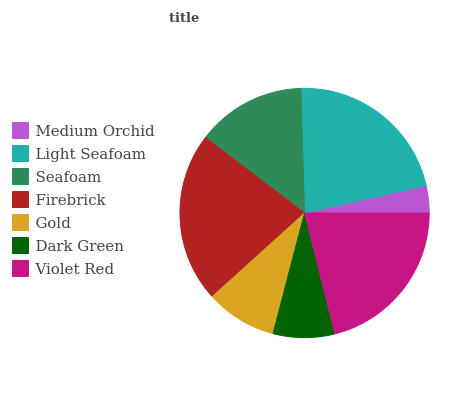Is Medium Orchid the minimum?
Answer yes or no. Yes. Is Firebrick the maximum?
Answer yes or no. Yes. Is Light Seafoam the minimum?
Answer yes or no. No. Is Light Seafoam the maximum?
Answer yes or no. No. Is Light Seafoam greater than Medium Orchid?
Answer yes or no. Yes. Is Medium Orchid less than Light Seafoam?
Answer yes or no. Yes. Is Medium Orchid greater than Light Seafoam?
Answer yes or no. No. Is Light Seafoam less than Medium Orchid?
Answer yes or no. No. Is Seafoam the high median?
Answer yes or no. Yes. Is Seafoam the low median?
Answer yes or no. Yes. Is Dark Green the high median?
Answer yes or no. No. Is Medium Orchid the low median?
Answer yes or no. No. 